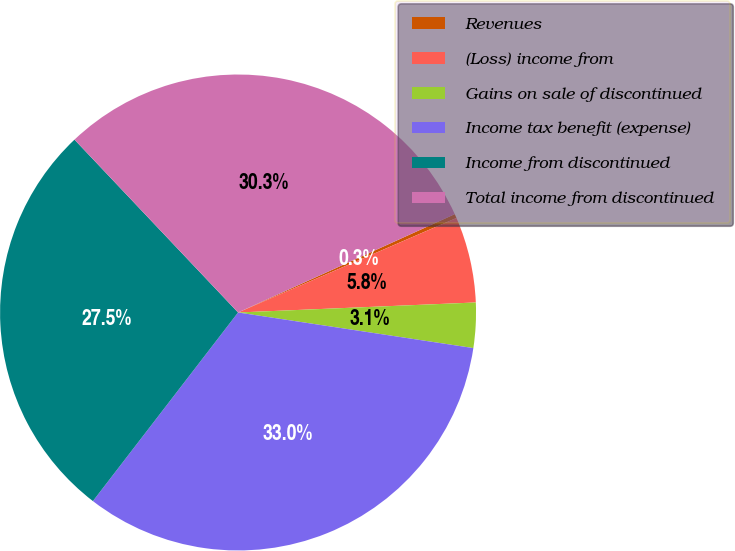<chart> <loc_0><loc_0><loc_500><loc_500><pie_chart><fcel>Revenues<fcel>(Loss) income from<fcel>Gains on sale of discontinued<fcel>Income tax benefit (expense)<fcel>Income from discontinued<fcel>Total income from discontinued<nl><fcel>0.28%<fcel>5.83%<fcel>3.06%<fcel>33.05%<fcel>27.5%<fcel>30.28%<nl></chart> 